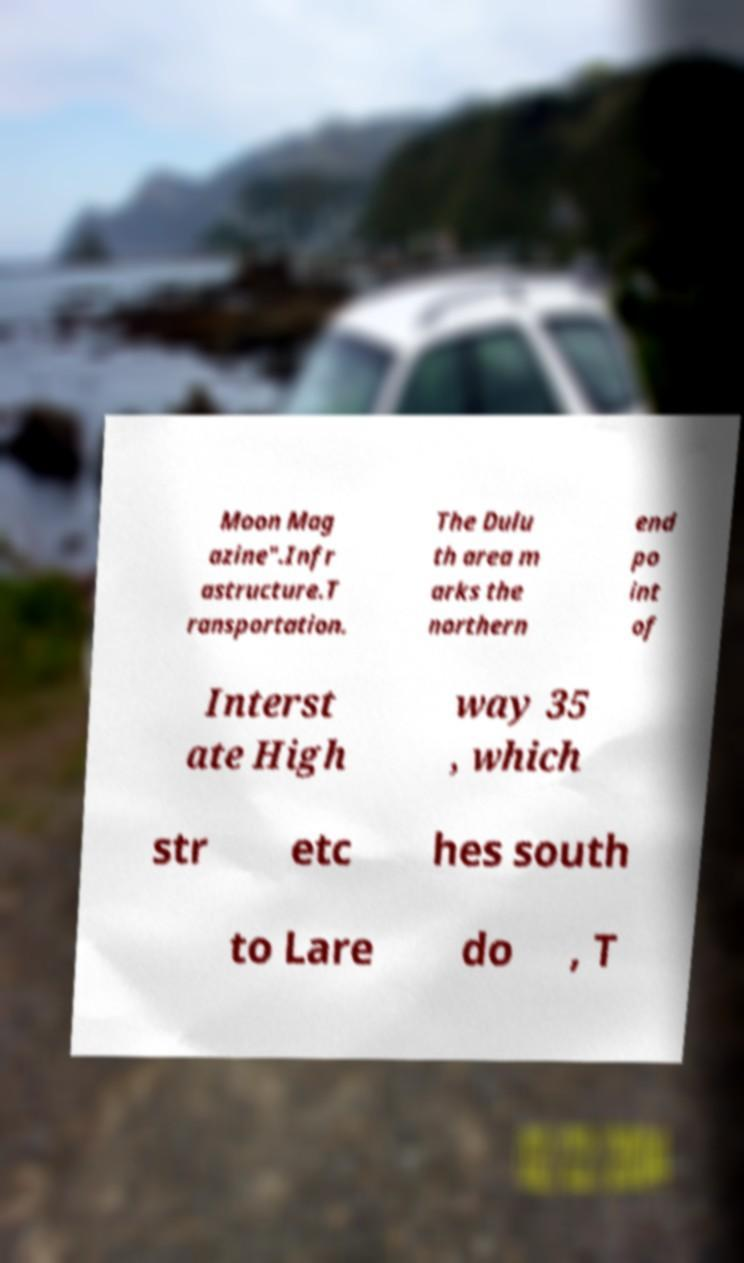Can you accurately transcribe the text from the provided image for me? Moon Mag azine".Infr astructure.T ransportation. The Dulu th area m arks the northern end po int of Interst ate High way 35 , which str etc hes south to Lare do , T 